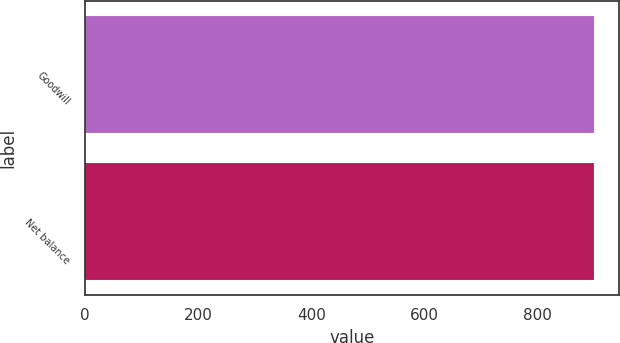Convert chart to OTSL. <chart><loc_0><loc_0><loc_500><loc_500><bar_chart><fcel>Goodwill<fcel>Net balance<nl><fcel>899<fcel>899.1<nl></chart> 